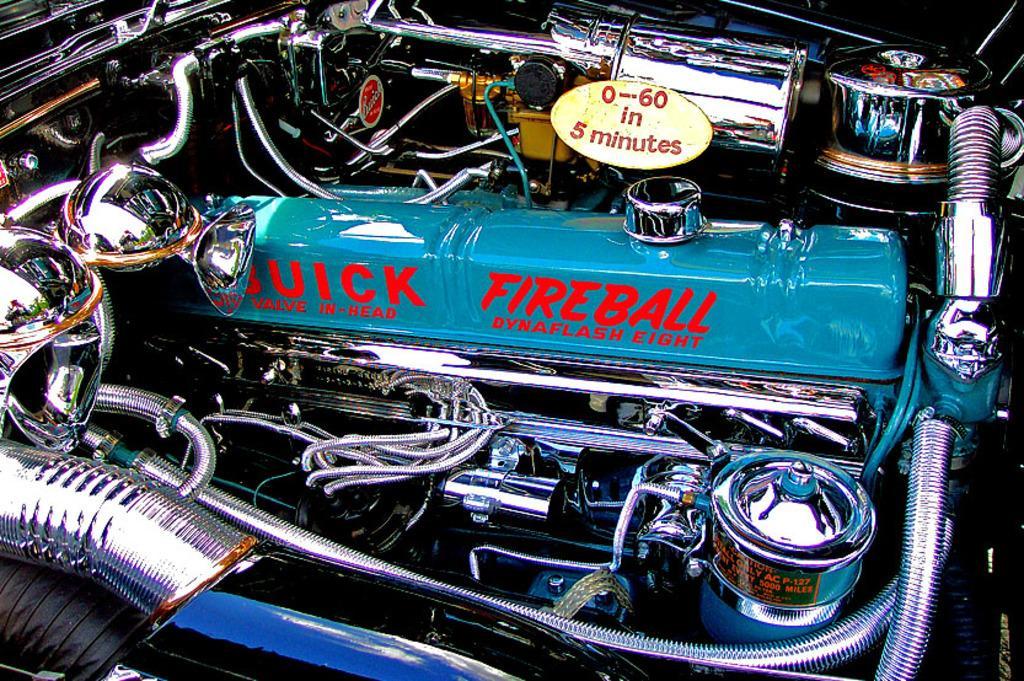Can you describe this image briefly? In the picture we can see a car engine with diesel tank and some wires and pipes. 